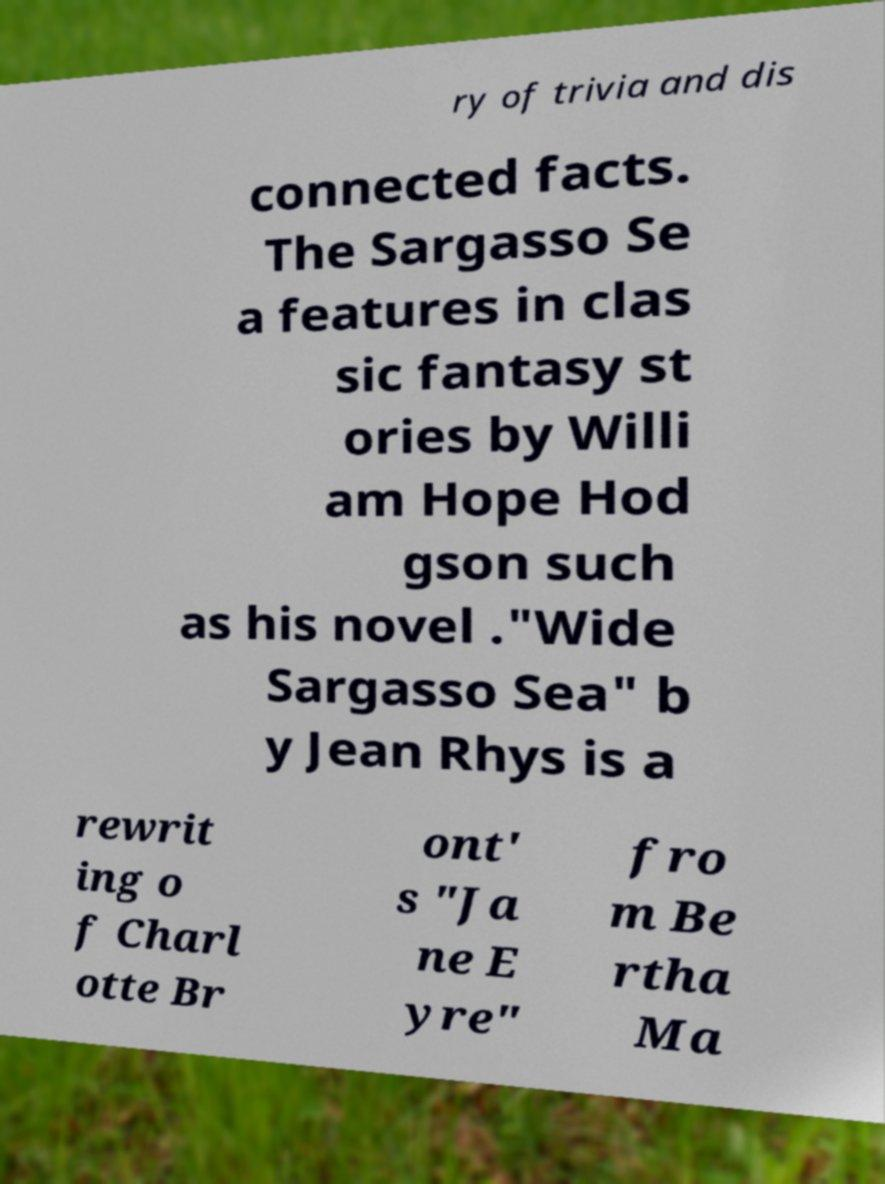What messages or text are displayed in this image? I need them in a readable, typed format. ry of trivia and dis connected facts. The Sargasso Se a features in clas sic fantasy st ories by Willi am Hope Hod gson such as his novel ."Wide Sargasso Sea" b y Jean Rhys is a rewrit ing o f Charl otte Br ont' s "Ja ne E yre" fro m Be rtha Ma 